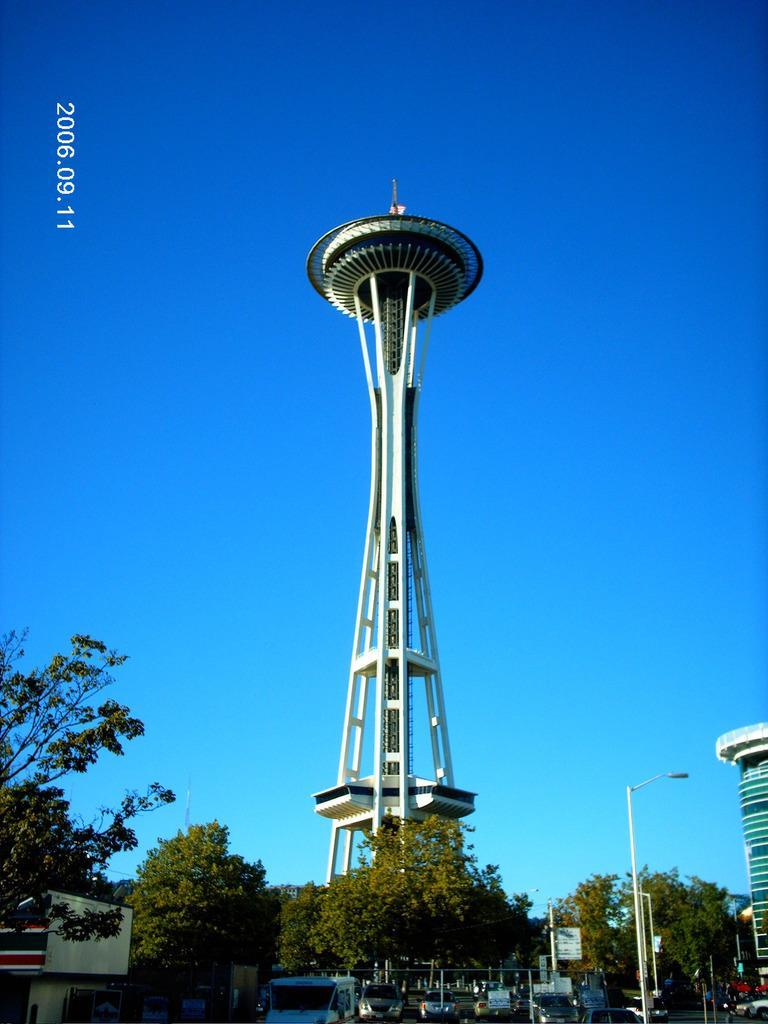Could you give a brief overview of what you see in this image? On the down side there are green color trees. In the middle it's a big tower and this is a blue color sky. 